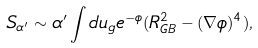<formula> <loc_0><loc_0><loc_500><loc_500>S _ { \alpha ^ { \prime } } \sim \alpha ^ { \prime } \int d u _ { g } e ^ { - \phi } ( R ^ { 2 } _ { G B } - ( \nabla \phi ) ^ { 4 } ) ,</formula> 